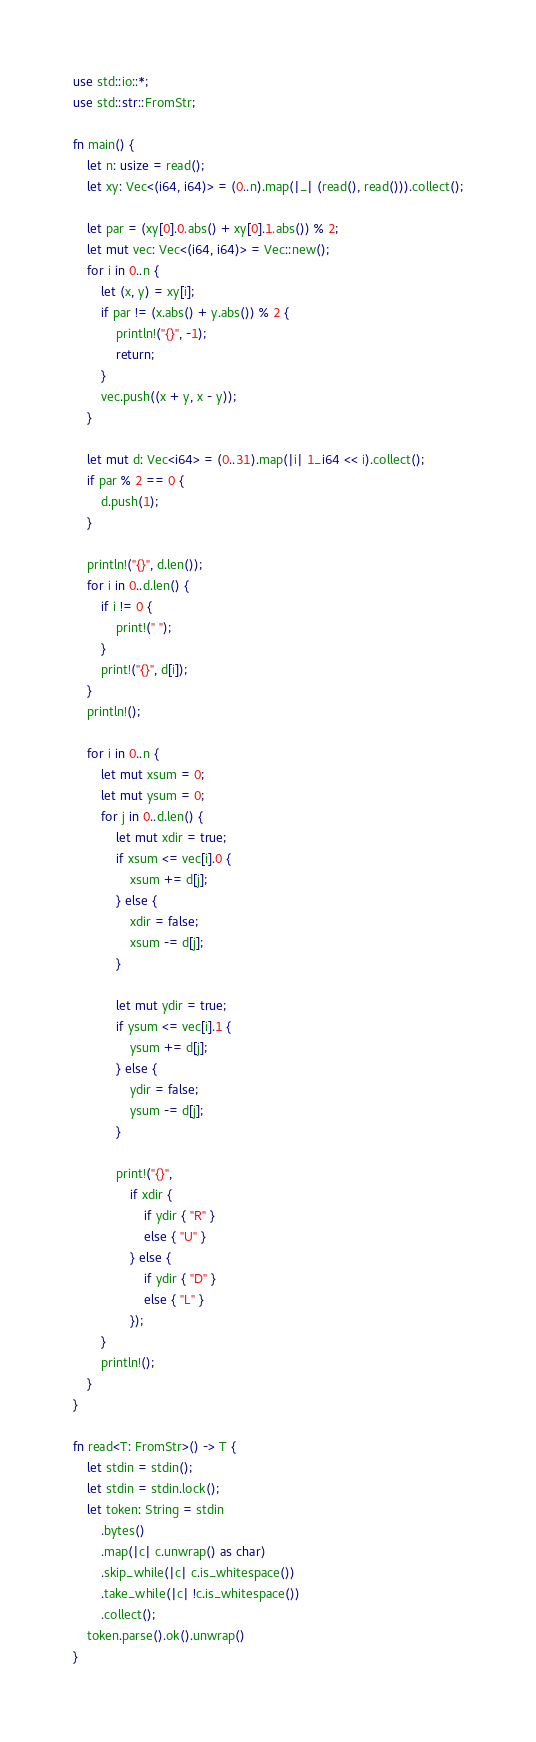<code> <loc_0><loc_0><loc_500><loc_500><_Rust_>use std::io::*;
use std::str::FromStr;

fn main() {
    let n: usize = read();
    let xy: Vec<(i64, i64)> = (0..n).map(|_| (read(), read())).collect();

    let par = (xy[0].0.abs() + xy[0].1.abs()) % 2;
    let mut vec: Vec<(i64, i64)> = Vec::new();
    for i in 0..n {
        let (x, y) = xy[i];
        if par != (x.abs() + y.abs()) % 2 {
            println!("{}", -1);
            return;
        }
        vec.push((x + y, x - y));
    }

    let mut d: Vec<i64> = (0..31).map(|i| 1_i64 << i).collect();
    if par % 2 == 0 {
        d.push(1);
    }

    println!("{}", d.len());
    for i in 0..d.len() {
        if i != 0 {
            print!(" ");
        }
        print!("{}", d[i]);
    }
    println!();

    for i in 0..n {
        let mut xsum = 0;
        let mut ysum = 0;
        for j in 0..d.len() {
            let mut xdir = true;
            if xsum <= vec[i].0 {
                xsum += d[j];
            } else {
                xdir = false;
                xsum -= d[j];
            }

            let mut ydir = true;
            if ysum <= vec[i].1 {
                ysum += d[j];
            } else {
                ydir = false;
                ysum -= d[j];
            }

            print!("{}", 
                if xdir {
                    if ydir { "R" }
                    else { "U" }
                } else {
                    if ydir { "D" }
                    else { "L" }
                });
        }
        println!();
    }
}

fn read<T: FromStr>() -> T {
    let stdin = stdin();
    let stdin = stdin.lock();
    let token: String = stdin
        .bytes()
        .map(|c| c.unwrap() as char)
        .skip_while(|c| c.is_whitespace())
        .take_while(|c| !c.is_whitespace())
        .collect();
    token.parse().ok().unwrap()
}
</code> 